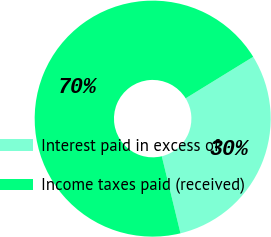Convert chart. <chart><loc_0><loc_0><loc_500><loc_500><pie_chart><fcel>Interest paid in excess of<fcel>Income taxes paid (received)<nl><fcel>29.99%<fcel>70.01%<nl></chart> 